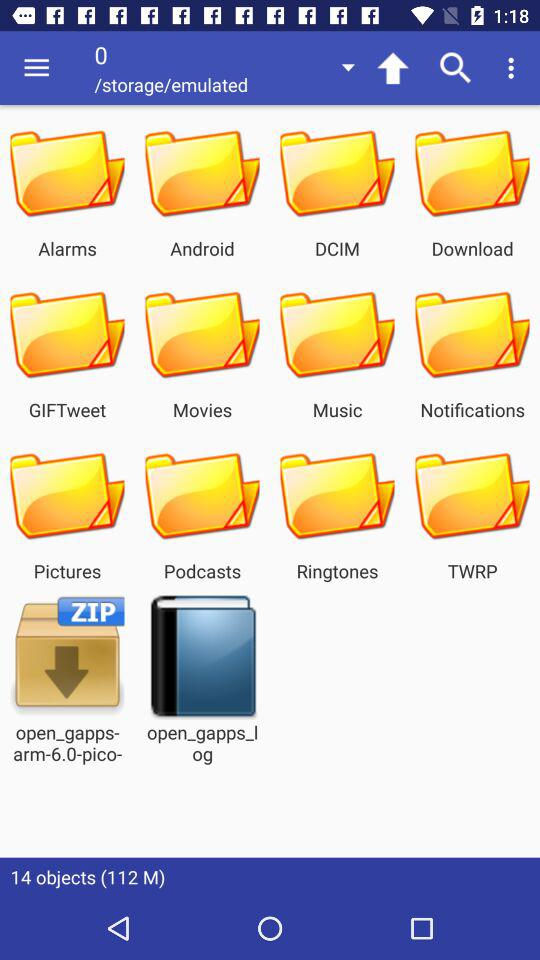Who is this application powered by?
When the provided information is insufficient, respond with <no answer>. <no answer> 